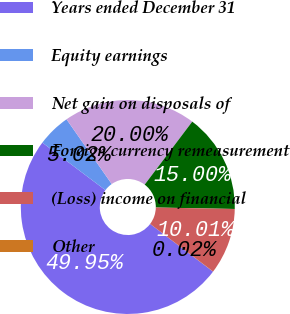<chart> <loc_0><loc_0><loc_500><loc_500><pie_chart><fcel>Years ended December 31<fcel>Equity earnings<fcel>Net gain on disposals of<fcel>Foreign currency remeasurement<fcel>(Loss) income on financial<fcel>Other<nl><fcel>49.95%<fcel>5.02%<fcel>20.0%<fcel>15.0%<fcel>10.01%<fcel>0.02%<nl></chart> 